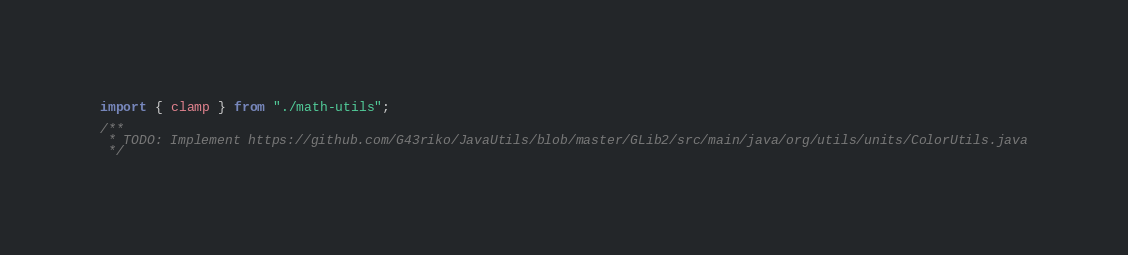Convert code to text. <code><loc_0><loc_0><loc_500><loc_500><_TypeScript_>import { clamp } from "./math-utils";

/**
 * TODO: Implement https://github.com/G43riko/JavaUtils/blob/master/GLib2/src/main/java/org/utils/units/ColorUtils.java
 */
</code> 